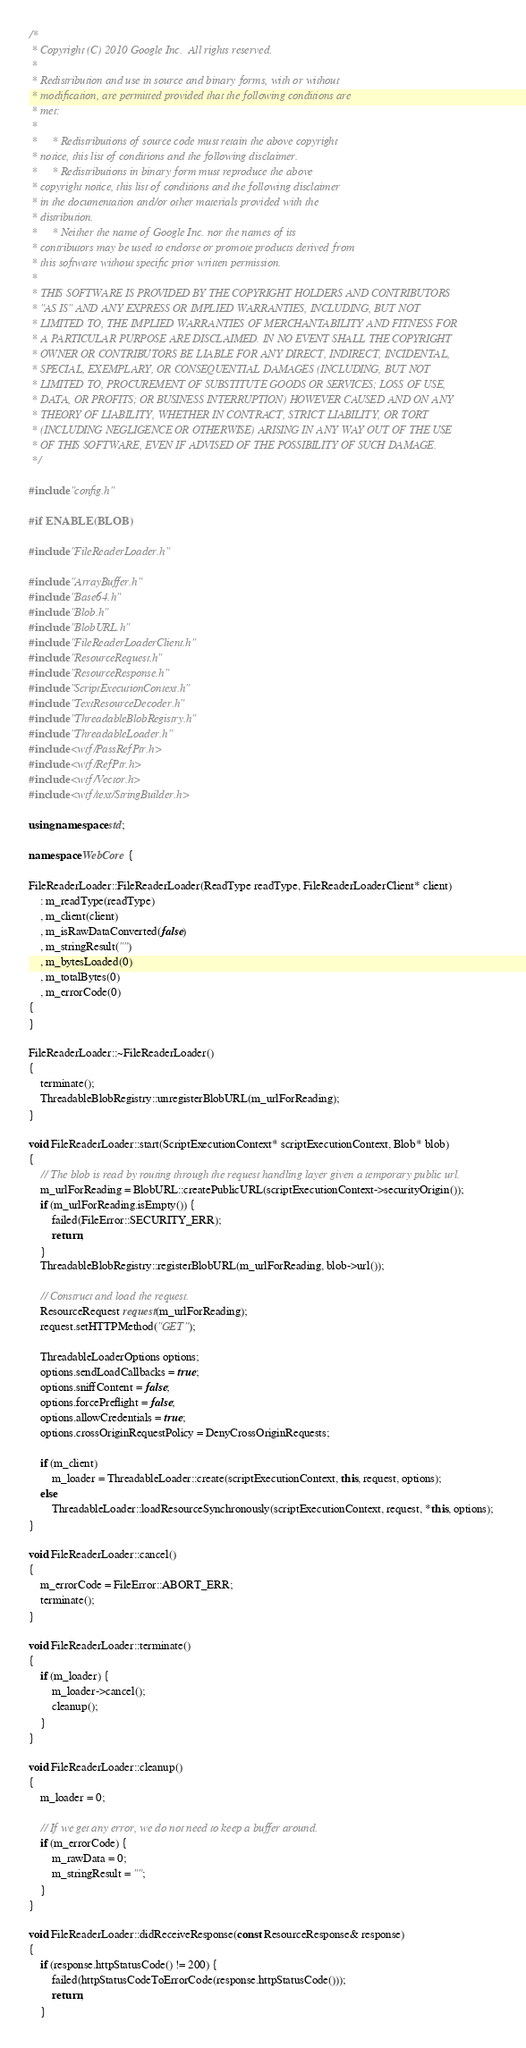Convert code to text. <code><loc_0><loc_0><loc_500><loc_500><_C++_>/*
 * Copyright (C) 2010 Google Inc.  All rights reserved.
 *
 * Redistribution and use in source and binary forms, with or without
 * modification, are permitted provided that the following conditions are
 * met:
 *
 *     * Redistributions of source code must retain the above copyright
 * notice, this list of conditions and the following disclaimer.
 *     * Redistributions in binary form must reproduce the above
 * copyright notice, this list of conditions and the following disclaimer
 * in the documentation and/or other materials provided with the
 * distribution.
 *     * Neither the name of Google Inc. nor the names of its
 * contributors may be used to endorse or promote products derived from
 * this software without specific prior written permission.
 *
 * THIS SOFTWARE IS PROVIDED BY THE COPYRIGHT HOLDERS AND CONTRIBUTORS
 * "AS IS" AND ANY EXPRESS OR IMPLIED WARRANTIES, INCLUDING, BUT NOT
 * LIMITED TO, THE IMPLIED WARRANTIES OF MERCHANTABILITY AND FITNESS FOR
 * A PARTICULAR PURPOSE ARE DISCLAIMED. IN NO EVENT SHALL THE COPYRIGHT
 * OWNER OR CONTRIBUTORS BE LIABLE FOR ANY DIRECT, INDIRECT, INCIDENTAL,
 * SPECIAL, EXEMPLARY, OR CONSEQUENTIAL DAMAGES (INCLUDING, BUT NOT
 * LIMITED TO, PROCUREMENT OF SUBSTITUTE GOODS OR SERVICES; LOSS OF USE,
 * DATA, OR PROFITS; OR BUSINESS INTERRUPTION) HOWEVER CAUSED AND ON ANY
 * THEORY OF LIABILITY, WHETHER IN CONTRACT, STRICT LIABILITY, OR TORT
 * (INCLUDING NEGLIGENCE OR OTHERWISE) ARISING IN ANY WAY OUT OF THE USE
 * OF THIS SOFTWARE, EVEN IF ADVISED OF THE POSSIBILITY OF SUCH DAMAGE.
 */

#include "config.h"

#if ENABLE(BLOB)

#include "FileReaderLoader.h"

#include "ArrayBuffer.h"
#include "Base64.h"
#include "Blob.h"
#include "BlobURL.h"
#include "FileReaderLoaderClient.h"
#include "ResourceRequest.h"
#include "ResourceResponse.h"
#include "ScriptExecutionContext.h"
#include "TextResourceDecoder.h"
#include "ThreadableBlobRegistry.h"
#include "ThreadableLoader.h"
#include <wtf/PassRefPtr.h>
#include <wtf/RefPtr.h>
#include <wtf/Vector.h>
#include <wtf/text/StringBuilder.h>

using namespace std;

namespace WebCore {

FileReaderLoader::FileReaderLoader(ReadType readType, FileReaderLoaderClient* client)
    : m_readType(readType)
    , m_client(client)
    , m_isRawDataConverted(false)
    , m_stringResult("")
    , m_bytesLoaded(0)
    , m_totalBytes(0)
    , m_errorCode(0)
{
}

FileReaderLoader::~FileReaderLoader()
{
    terminate();
    ThreadableBlobRegistry::unregisterBlobURL(m_urlForReading);
}

void FileReaderLoader::start(ScriptExecutionContext* scriptExecutionContext, Blob* blob)
{
    // The blob is read by routing through the request handling layer given a temporary public url.
    m_urlForReading = BlobURL::createPublicURL(scriptExecutionContext->securityOrigin());
    if (m_urlForReading.isEmpty()) {
        failed(FileError::SECURITY_ERR);
        return;
    }
    ThreadableBlobRegistry::registerBlobURL(m_urlForReading, blob->url());

    // Construct and load the request.
    ResourceRequest request(m_urlForReading);
    request.setHTTPMethod("GET");

    ThreadableLoaderOptions options;
    options.sendLoadCallbacks = true;
    options.sniffContent = false;
    options.forcePreflight = false;
    options.allowCredentials = true;
    options.crossOriginRequestPolicy = DenyCrossOriginRequests;

    if (m_client)
        m_loader = ThreadableLoader::create(scriptExecutionContext, this, request, options);
    else
        ThreadableLoader::loadResourceSynchronously(scriptExecutionContext, request, *this, options);
}

void FileReaderLoader::cancel()
{
    m_errorCode = FileError::ABORT_ERR;
    terminate();
}

void FileReaderLoader::terminate()
{
    if (m_loader) {
        m_loader->cancel();
        cleanup();
    }
}

void FileReaderLoader::cleanup()
{
    m_loader = 0;

    // If we get any error, we do not need to keep a buffer around.
    if (m_errorCode) {
        m_rawData = 0;
        m_stringResult = "";
    }
}

void FileReaderLoader::didReceiveResponse(const ResourceResponse& response)
{
    if (response.httpStatusCode() != 200) {
        failed(httpStatusCodeToErrorCode(response.httpStatusCode()));
        return;
    }
</code> 